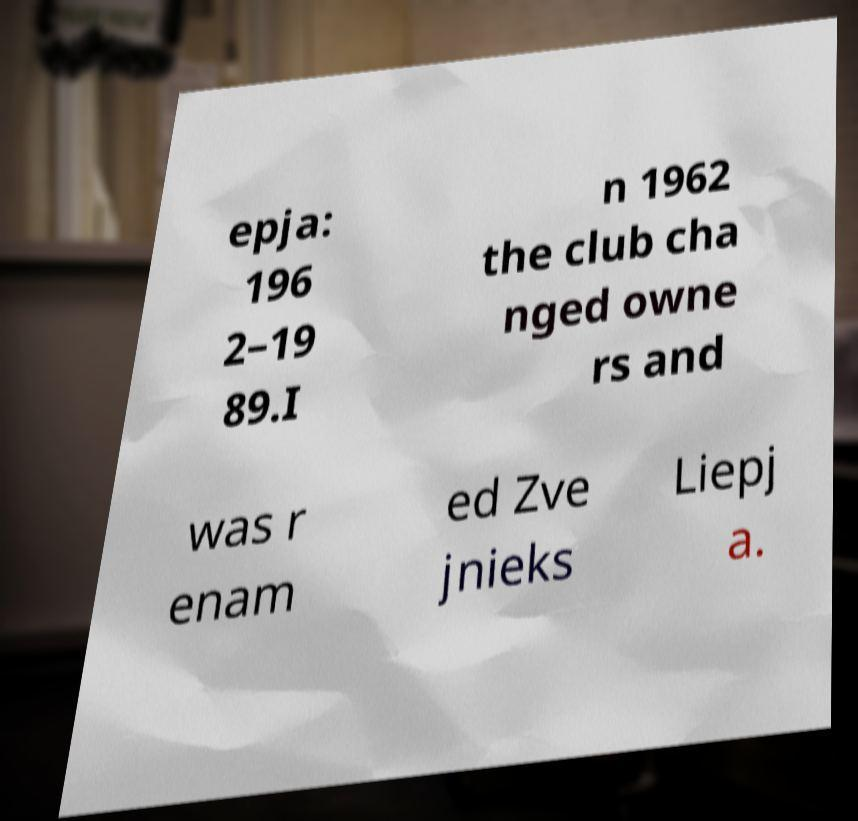What messages or text are displayed in this image? I need them in a readable, typed format. epja: 196 2–19 89.I n 1962 the club cha nged owne rs and was r enam ed Zve jnieks Liepj a. 